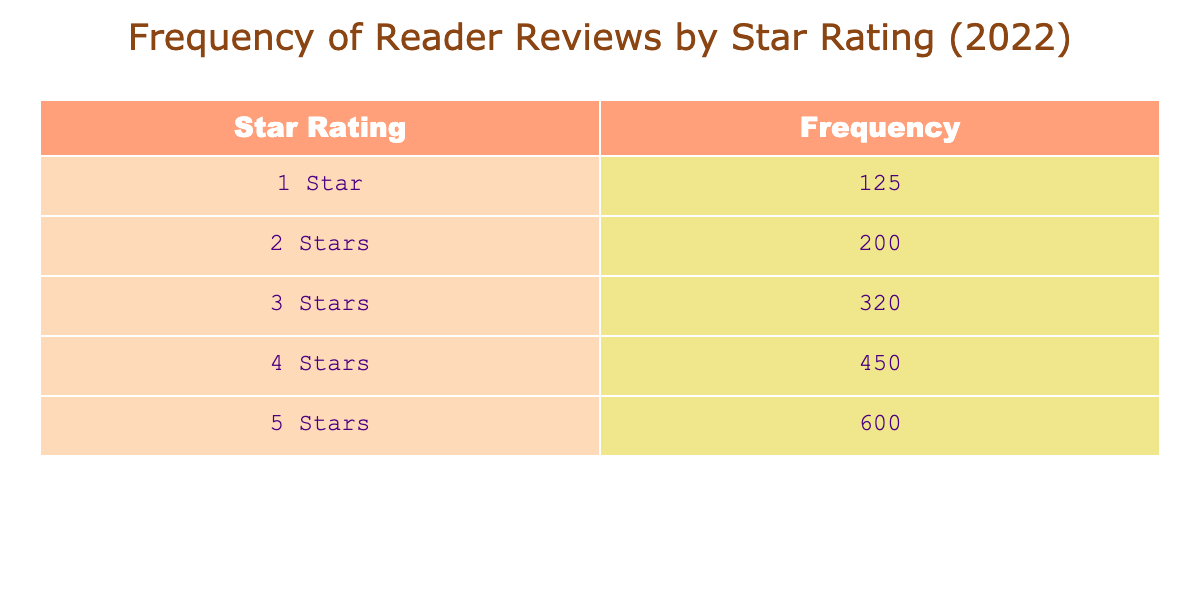What is the frequency of 1-star reviews? According to the table, the 1-star reviews have a frequency of 125. This value corresponds directly to the "1 Star" row in the table.
Answer: 125 What is the total frequency of reviews (all star ratings combined)? To find the total frequency, we add the frequencies of all star ratings: 125 (1 star) + 200 (2 stars) + 320 (3 stars) + 450 (4 stars) + 600 (5 stars) = 1695.
Answer: 1695 How many more 5-star reviews are there than 1-star reviews? The frequency of 5-star reviews is 600, and the frequency of 1-star reviews is 125. To find the difference, we subtract 125 from 600: 600 - 125 = 475.
Answer: 475 Is the frequency of 4-star reviews greater than that of 3-star reviews? The frequency of 4-star reviews is 450 and the frequency of 3-star reviews is 320. Since 450 is greater than 320, the answer is yes.
Answer: Yes What is the average frequency of reviews across all star ratings? To find the average, we sum all frequencies (125 + 200 + 320 + 450 + 600 = 1695) and divide by the number of categories (5): 1695 / 5 = 339.
Answer: 339 How many reviews are there for ratings below 4 stars combined? To find the total frequency of ratings below 4 stars (1 star, 2 stars, and 3 stars), we add their frequencies: 125 (1 star) + 200 (2 stars) + 320 (3 stars) = 645.
Answer: 645 Are there more 2-star reviews or 4-star reviews? The frequency of 2-star reviews is 200 and the frequency of 4-star reviews is 450. Since 200 is less than 450, the answer is no.
Answer: No What percentage of the total reviews are 5-star reviews? There are 600 5-star reviews. To calculate the percentage, we divide the number of 5-star reviews by the total frequency and multiply by 100: (600 / 1695) * 100 ≈ 35.39%.
Answer: 35.39% Which star rating received the most reviews? Comparing the frequencies, 5-star reviews have the highest frequency at 600, making it the most reviewed star rating.
Answer: 5 Stars 